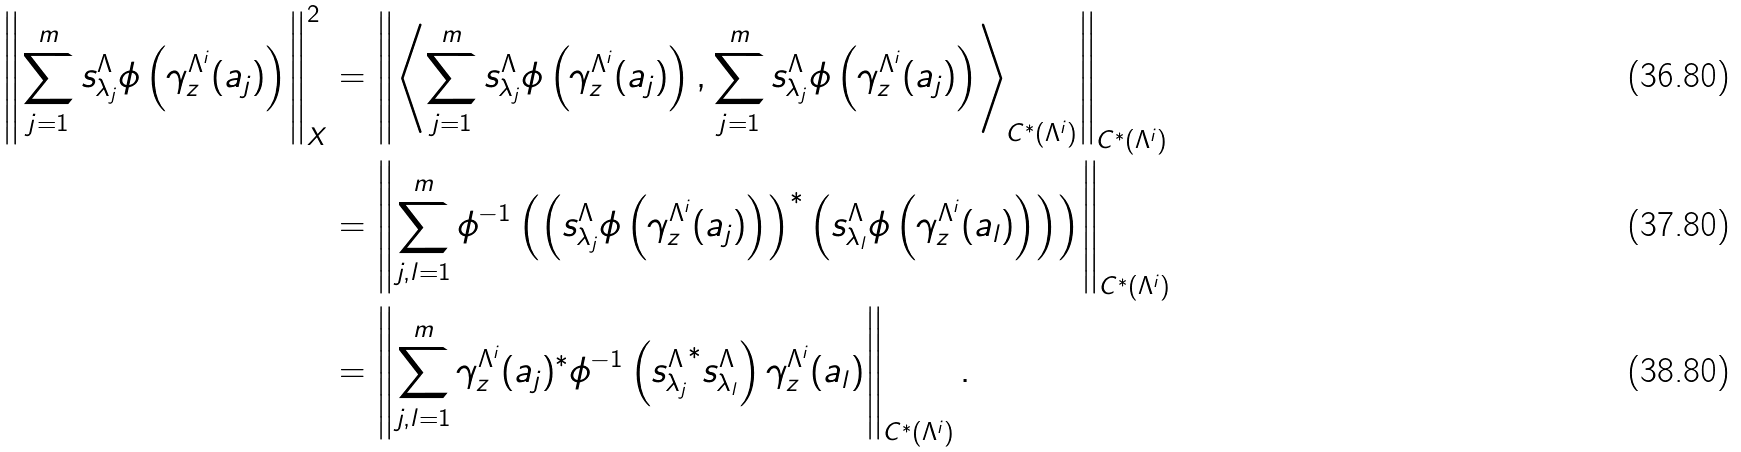<formula> <loc_0><loc_0><loc_500><loc_500>\left \| \sum _ { j = 1 } ^ { m } s _ { \lambda _ { j } } ^ { \Lambda } \phi \left ( \gamma ^ { \Lambda ^ { i } } _ { z } ( a _ { j } ) \right ) \right \| _ { X } ^ { 2 } & = \left \| \left \langle \sum _ { j = 1 } ^ { m } s _ { \lambda _ { j } } ^ { \Lambda } \phi \left ( \gamma ^ { \Lambda ^ { i } } _ { z } ( a _ { j } ) \right ) , \sum _ { j = 1 } ^ { m } s _ { \lambda _ { j } } ^ { \Lambda } \phi \left ( \gamma ^ { \Lambda ^ { i } } _ { z } ( a _ { j } ) \right ) \right \rangle _ { C ^ { * } ( \Lambda ^ { i } ) } \right \| _ { C ^ { * } ( \Lambda ^ { i } ) } \\ & = \left \| \sum _ { j , l = 1 } ^ { m } \phi ^ { - 1 } \left ( \left ( s _ { \lambda _ { j } } ^ { \Lambda } \phi \left ( \gamma ^ { \Lambda ^ { i } } _ { z } ( a _ { j } ) \right ) \right ) ^ { * } \left ( s _ { \lambda _ { l } } ^ { \Lambda } \phi \left ( \gamma ^ { \Lambda ^ { i } } _ { z } ( a _ { l } ) \right ) \right ) \right ) \right \| _ { C ^ { * } ( \Lambda ^ { i } ) } \\ & = \left \| \sum _ { j , l = 1 } ^ { m } \gamma ^ { \Lambda ^ { i } } _ { z } ( a _ { j } ) ^ { * } \phi ^ { - 1 } \left ( { s _ { \lambda _ { j } } ^ { \Lambda } } ^ { * } s _ { \lambda _ { l } } ^ { \Lambda } \right ) \gamma ^ { \Lambda ^ { i } } _ { z } ( a _ { l } ) \right \| _ { C ^ { * } ( \Lambda ^ { i } ) } .</formula> 